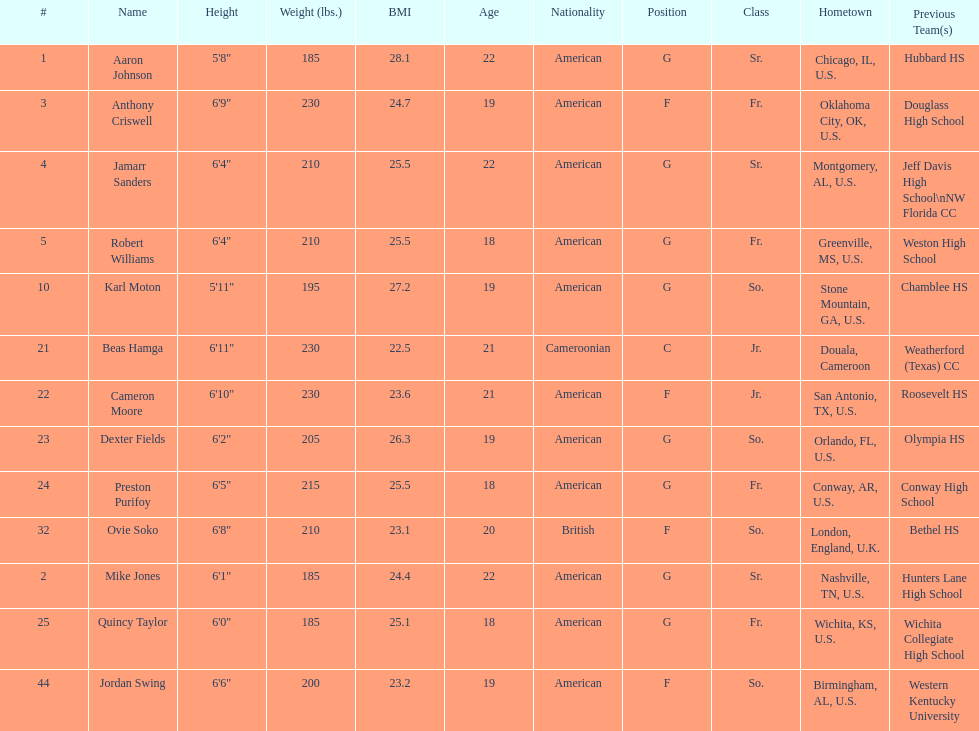How many total forwards are on the team? 4. 